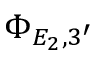Convert formula to latex. <formula><loc_0><loc_0><loc_500><loc_500>\Phi _ { E _ { 2 } , 3 ^ { \prime } }</formula> 